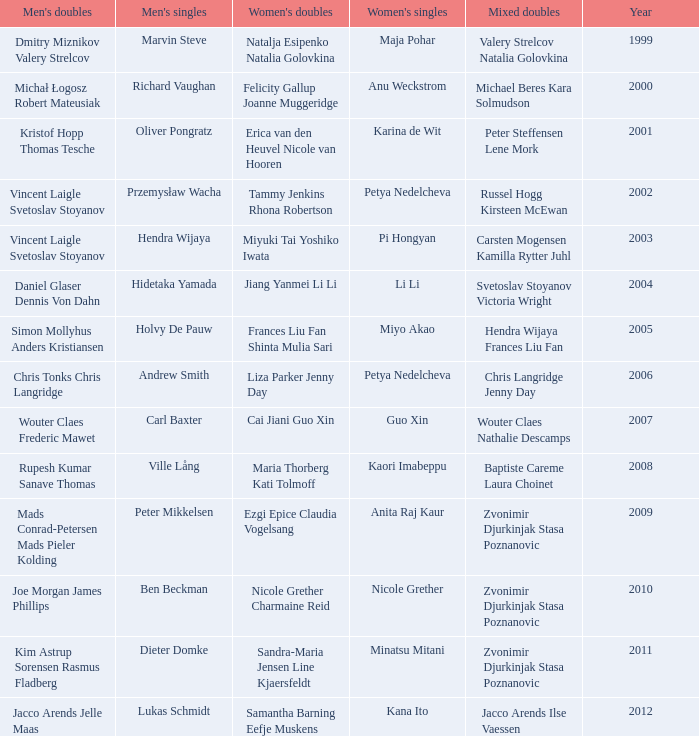Give the earliest year that featured Pi Hongyan on women's singles. 2003.0. 